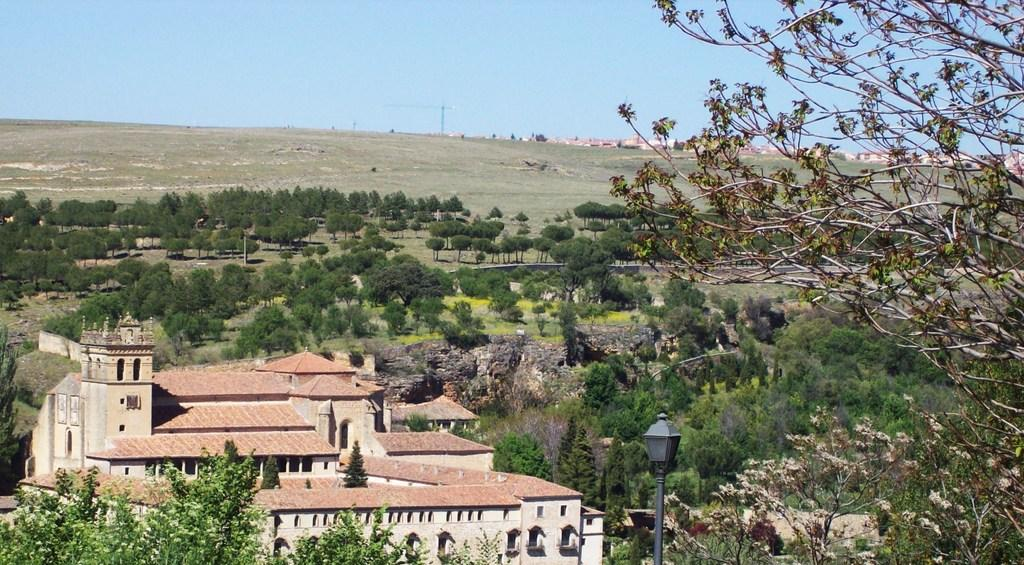What type of structure is present in the image? There is a building with windows in the image. What natural elements can be seen in the image? Trees are visible in the image. Can you describe the landscape in the image? The image appears to depict a hill. What man-made object is present in the image? There is a light pole in the image. What else can be seen in the background of the image? In the background, there is a pole and other buildings. Where is the throne located in the image? There is no throne present in the image. What type of drink is being served in the image? There is no drink being served in the image. 